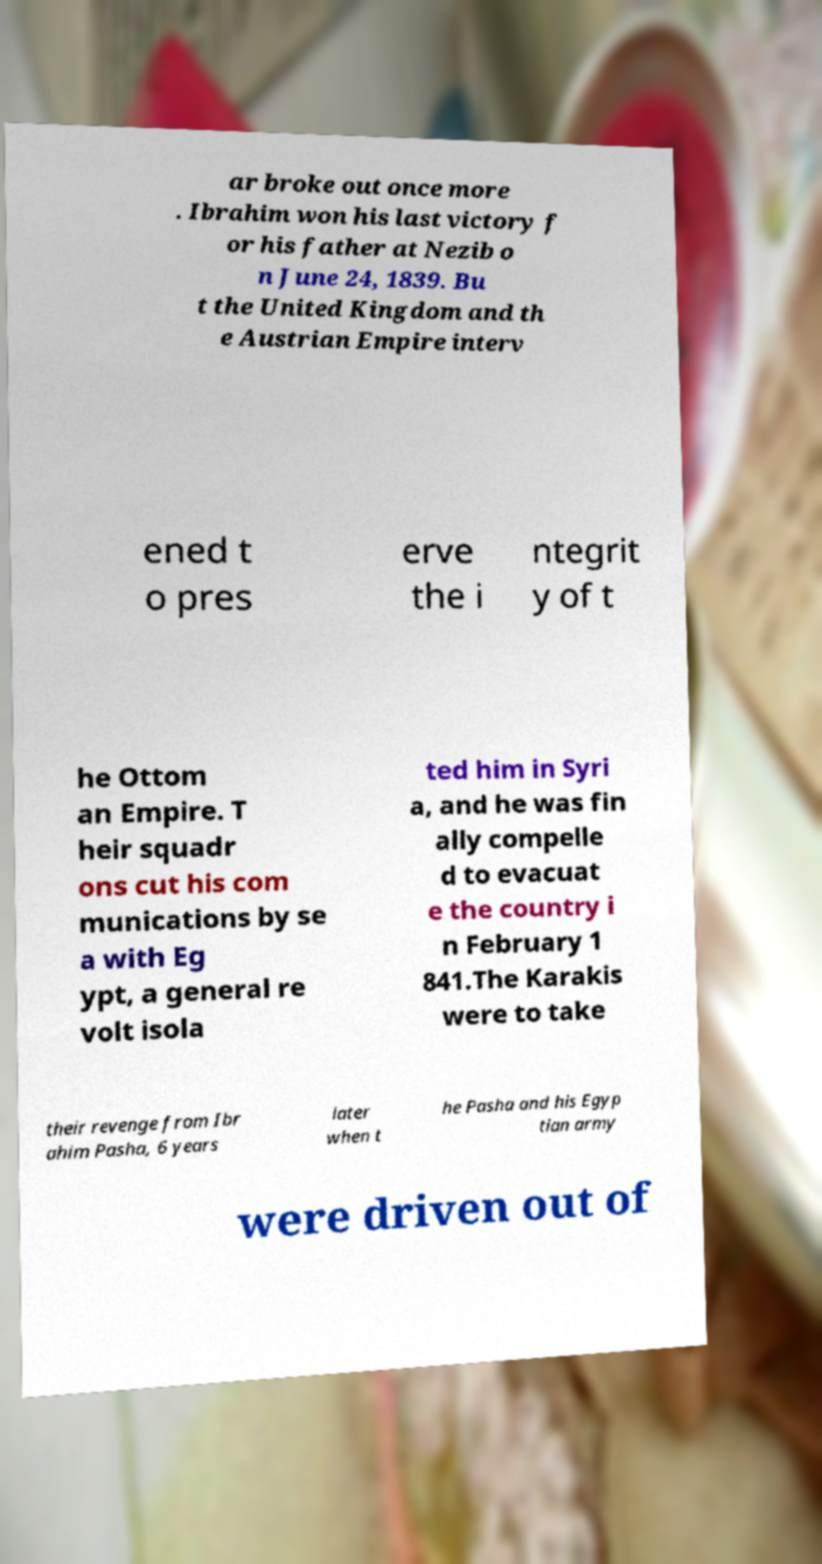I need the written content from this picture converted into text. Can you do that? ar broke out once more . Ibrahim won his last victory f or his father at Nezib o n June 24, 1839. Bu t the United Kingdom and th e Austrian Empire interv ened t o pres erve the i ntegrit y of t he Ottom an Empire. T heir squadr ons cut his com munications by se a with Eg ypt, a general re volt isola ted him in Syri a, and he was fin ally compelle d to evacuat e the country i n February 1 841.The Karakis were to take their revenge from Ibr ahim Pasha, 6 years later when t he Pasha and his Egyp tian army were driven out of 